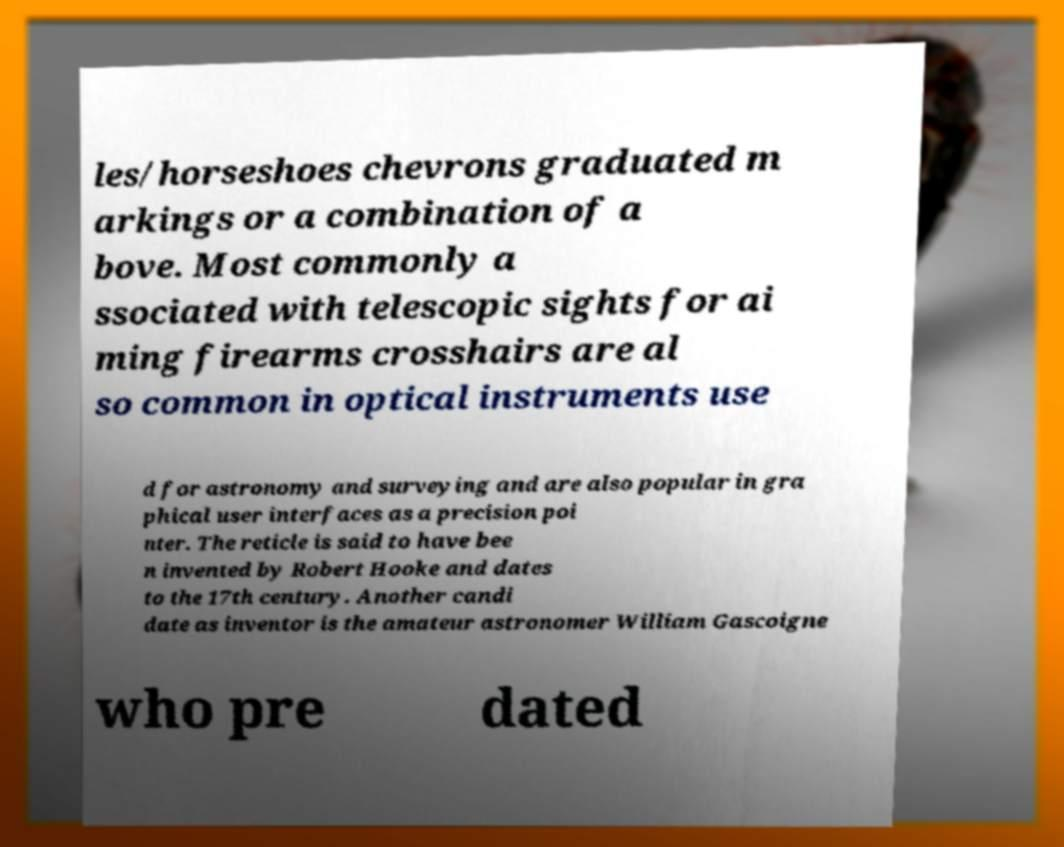There's text embedded in this image that I need extracted. Can you transcribe it verbatim? les/horseshoes chevrons graduated m arkings or a combination of a bove. Most commonly a ssociated with telescopic sights for ai ming firearms crosshairs are al so common in optical instruments use d for astronomy and surveying and are also popular in gra phical user interfaces as a precision poi nter. The reticle is said to have bee n invented by Robert Hooke and dates to the 17th century. Another candi date as inventor is the amateur astronomer William Gascoigne who pre dated 